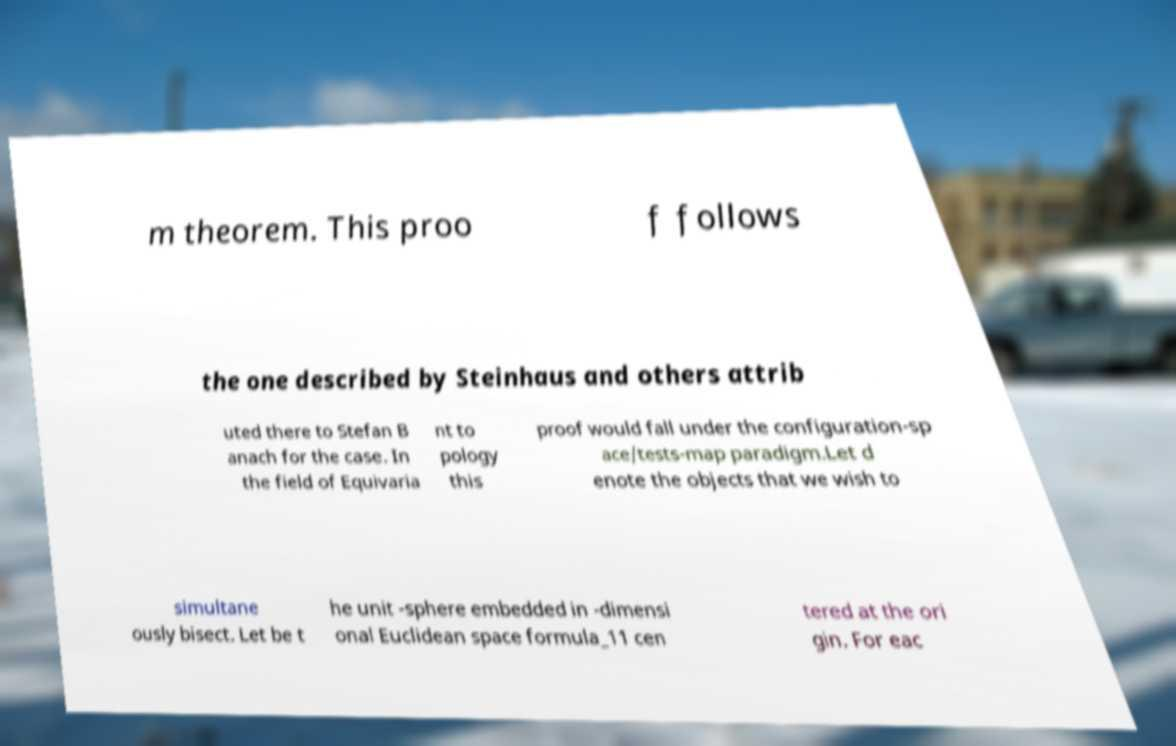I need the written content from this picture converted into text. Can you do that? m theorem. This proo f follows the one described by Steinhaus and others attrib uted there to Stefan B anach for the case. In the field of Equivaria nt to pology this proof would fall under the configuration-sp ace/tests-map paradigm.Let d enote the objects that we wish to simultane ously bisect. Let be t he unit -sphere embedded in -dimensi onal Euclidean space formula_11 cen tered at the ori gin. For eac 